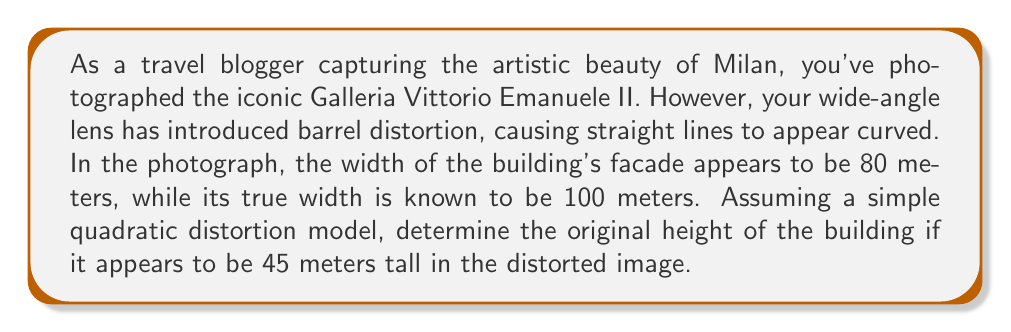What is the answer to this math problem? Let's approach this step-by-step:

1) In a simple quadratic distortion model, the relationship between the true coordinate (x) and the distorted coordinate (x') can be expressed as:

   $x' = x(1 + kr^2)$

   Where k is the distortion coefficient and r is the distance from the center of the image.

2) We know that the true width (W) is 100 meters and the distorted width (W') is 80 meters. Let's use this to find k:

   $80 = 100(1 + k(50)^2)$  (assuming the edge is at r = 50)
   $0.8 = 1 + 2500k$
   $k = -0.00008$

3) Now, let's apply this to the height. If H is the true height and H' is the distorted height:

   $45 = H(1 + k(H/2)^2)$  (assuming the top is at r = H/2)

4) Substituting k:

   $45 = H(1 - 0.00008(H/2)^2)$
   $45 = H - 0.00002H^3$

5) This is a cubic equation. We can solve it numerically or use the cubic formula. Using a numerical solver, we find:

   $H \approx 47.3699$ meters

Therefore, the original height of the building is approximately 47.37 meters.
Answer: 47.37 meters 